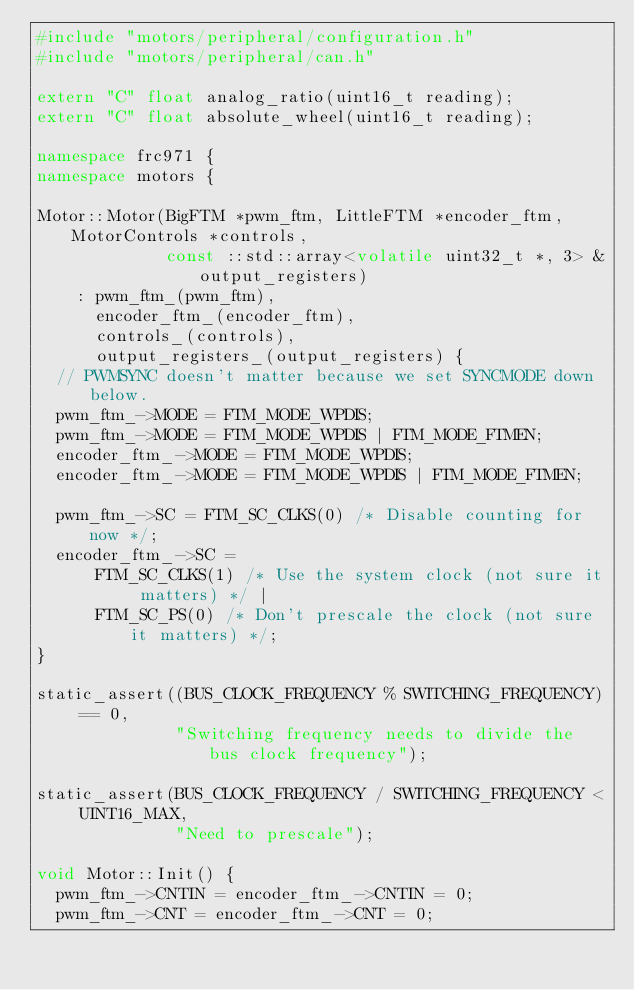Convert code to text. <code><loc_0><loc_0><loc_500><loc_500><_C++_>#include "motors/peripheral/configuration.h"
#include "motors/peripheral/can.h"

extern "C" float analog_ratio(uint16_t reading);
extern "C" float absolute_wheel(uint16_t reading);

namespace frc971 {
namespace motors {

Motor::Motor(BigFTM *pwm_ftm, LittleFTM *encoder_ftm, MotorControls *controls,
             const ::std::array<volatile uint32_t *, 3> &output_registers)
    : pwm_ftm_(pwm_ftm),
      encoder_ftm_(encoder_ftm),
      controls_(controls),
      output_registers_(output_registers) {
  // PWMSYNC doesn't matter because we set SYNCMODE down below.
  pwm_ftm_->MODE = FTM_MODE_WPDIS;
  pwm_ftm_->MODE = FTM_MODE_WPDIS | FTM_MODE_FTMEN;
  encoder_ftm_->MODE = FTM_MODE_WPDIS;
  encoder_ftm_->MODE = FTM_MODE_WPDIS | FTM_MODE_FTMEN;

  pwm_ftm_->SC = FTM_SC_CLKS(0) /* Disable counting for now */;
  encoder_ftm_->SC =
      FTM_SC_CLKS(1) /* Use the system clock (not sure it matters) */ |
      FTM_SC_PS(0) /* Don't prescale the clock (not sure it matters) */;
}

static_assert((BUS_CLOCK_FREQUENCY % SWITCHING_FREQUENCY) == 0,
              "Switching frequency needs to divide the bus clock frequency");

static_assert(BUS_CLOCK_FREQUENCY / SWITCHING_FREQUENCY < UINT16_MAX,
              "Need to prescale");

void Motor::Init() {
  pwm_ftm_->CNTIN = encoder_ftm_->CNTIN = 0;
  pwm_ftm_->CNT = encoder_ftm_->CNT = 0;
</code> 